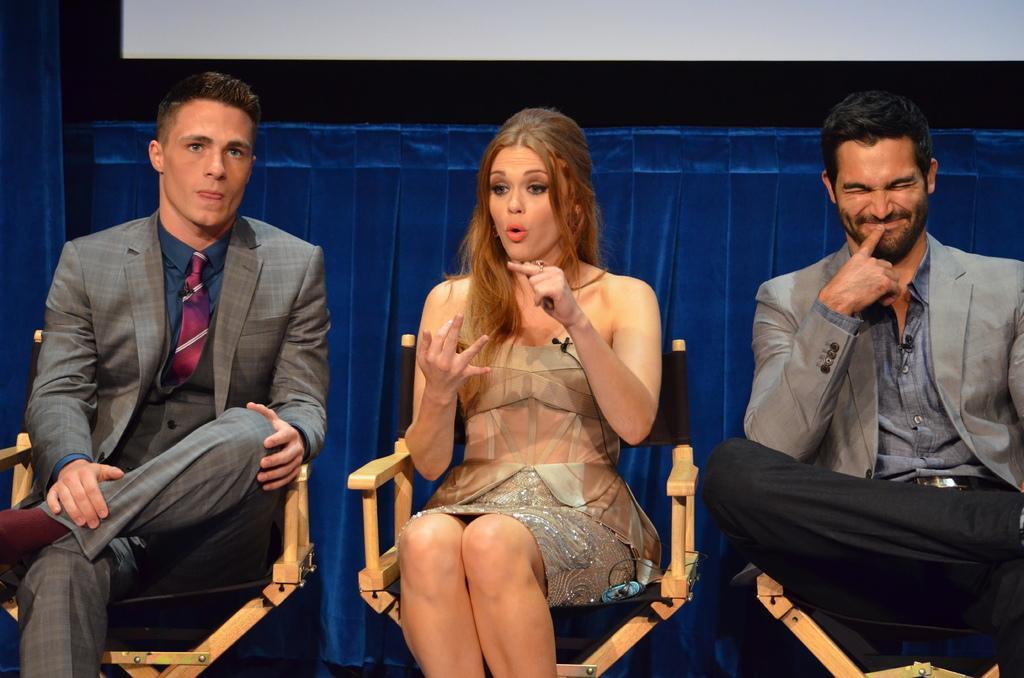Can you describe this image briefly? In this picture there are people those who are sitting in the center of the image, on the chairs and there is a blue color curtain in the background area of the image. 